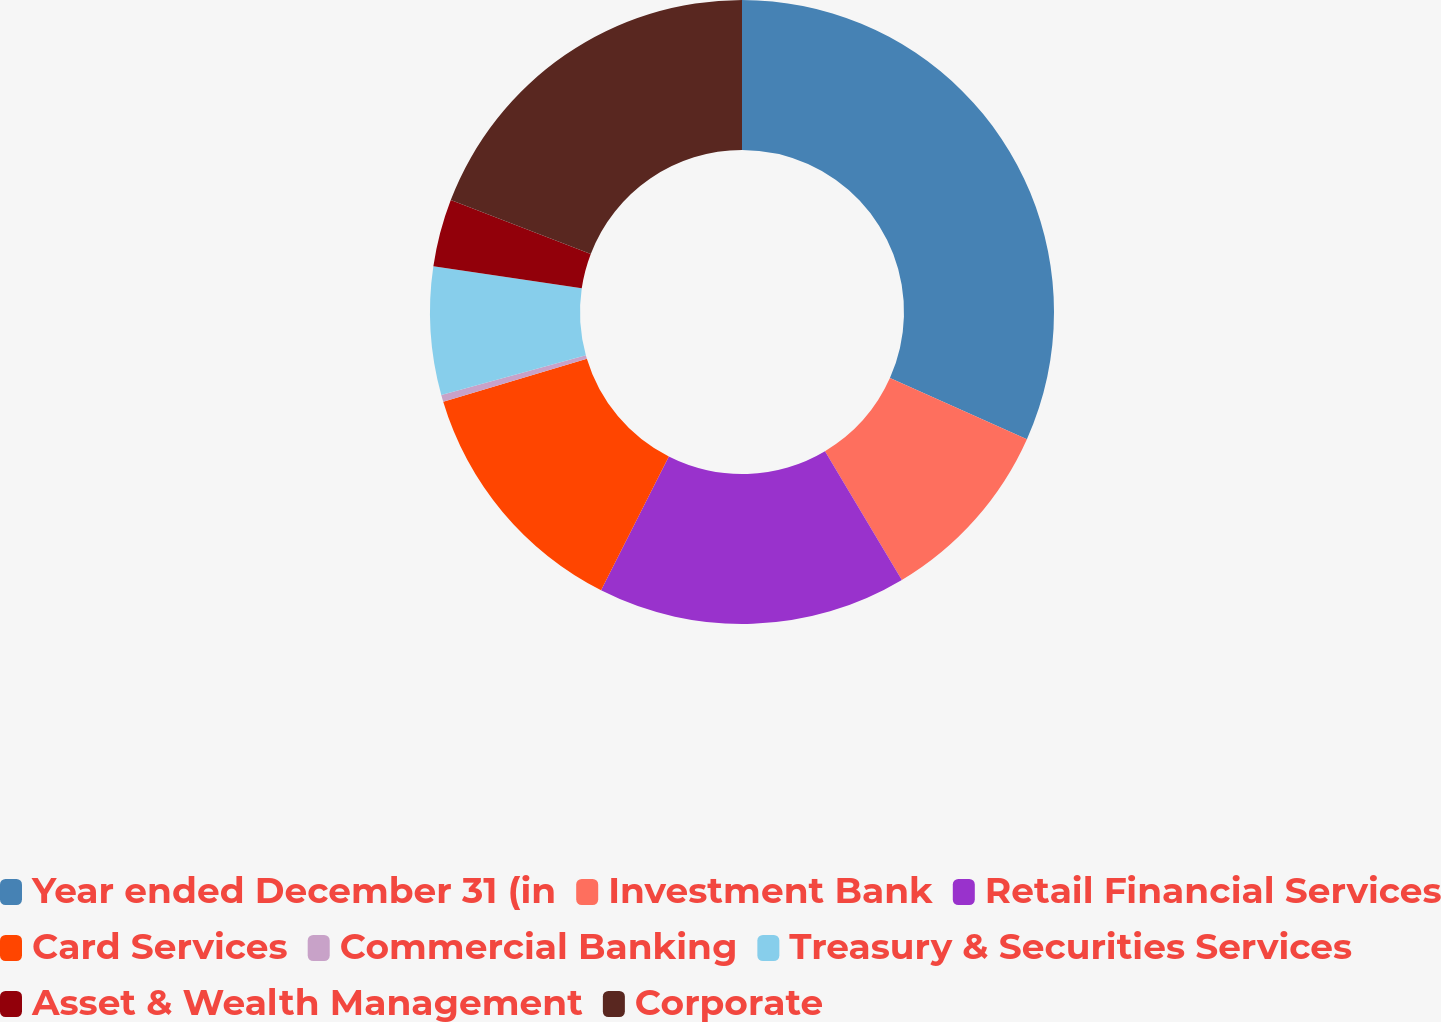Convert chart to OTSL. <chart><loc_0><loc_0><loc_500><loc_500><pie_chart><fcel>Year ended December 31 (in<fcel>Investment Bank<fcel>Retail Financial Services<fcel>Card Services<fcel>Commercial Banking<fcel>Treasury & Securities Services<fcel>Asset & Wealth Management<fcel>Corporate<nl><fcel>31.68%<fcel>9.76%<fcel>16.02%<fcel>12.89%<fcel>0.36%<fcel>6.63%<fcel>3.5%<fcel>19.16%<nl></chart> 